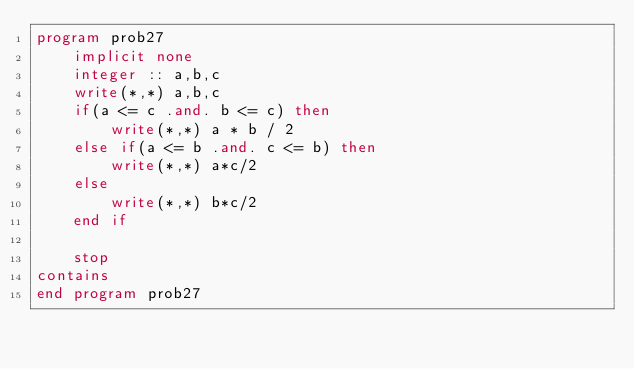Convert code to text. <code><loc_0><loc_0><loc_500><loc_500><_FORTRAN_>program prob27
    implicit none
    integer :: a,b,c
    write(*,*) a,b,c
    if(a <= c .and. b <= c) then
        write(*,*) a * b / 2
    else if(a <= b .and. c <= b) then
        write(*,*) a*c/2
    else
        write(*,*) b*c/2
    end if

    stop
contains
end program prob27</code> 